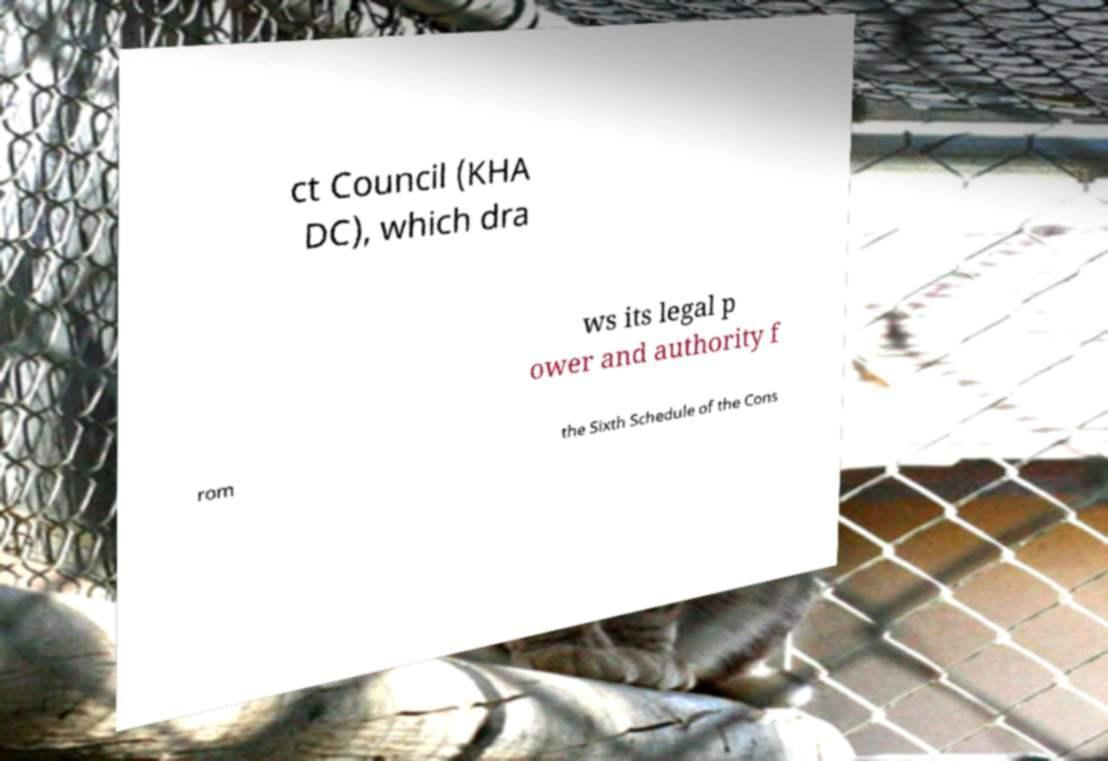What messages or text are displayed in this image? I need them in a readable, typed format. ct Council (KHA DC), which dra ws its legal p ower and authority f rom the Sixth Schedule of the Cons 